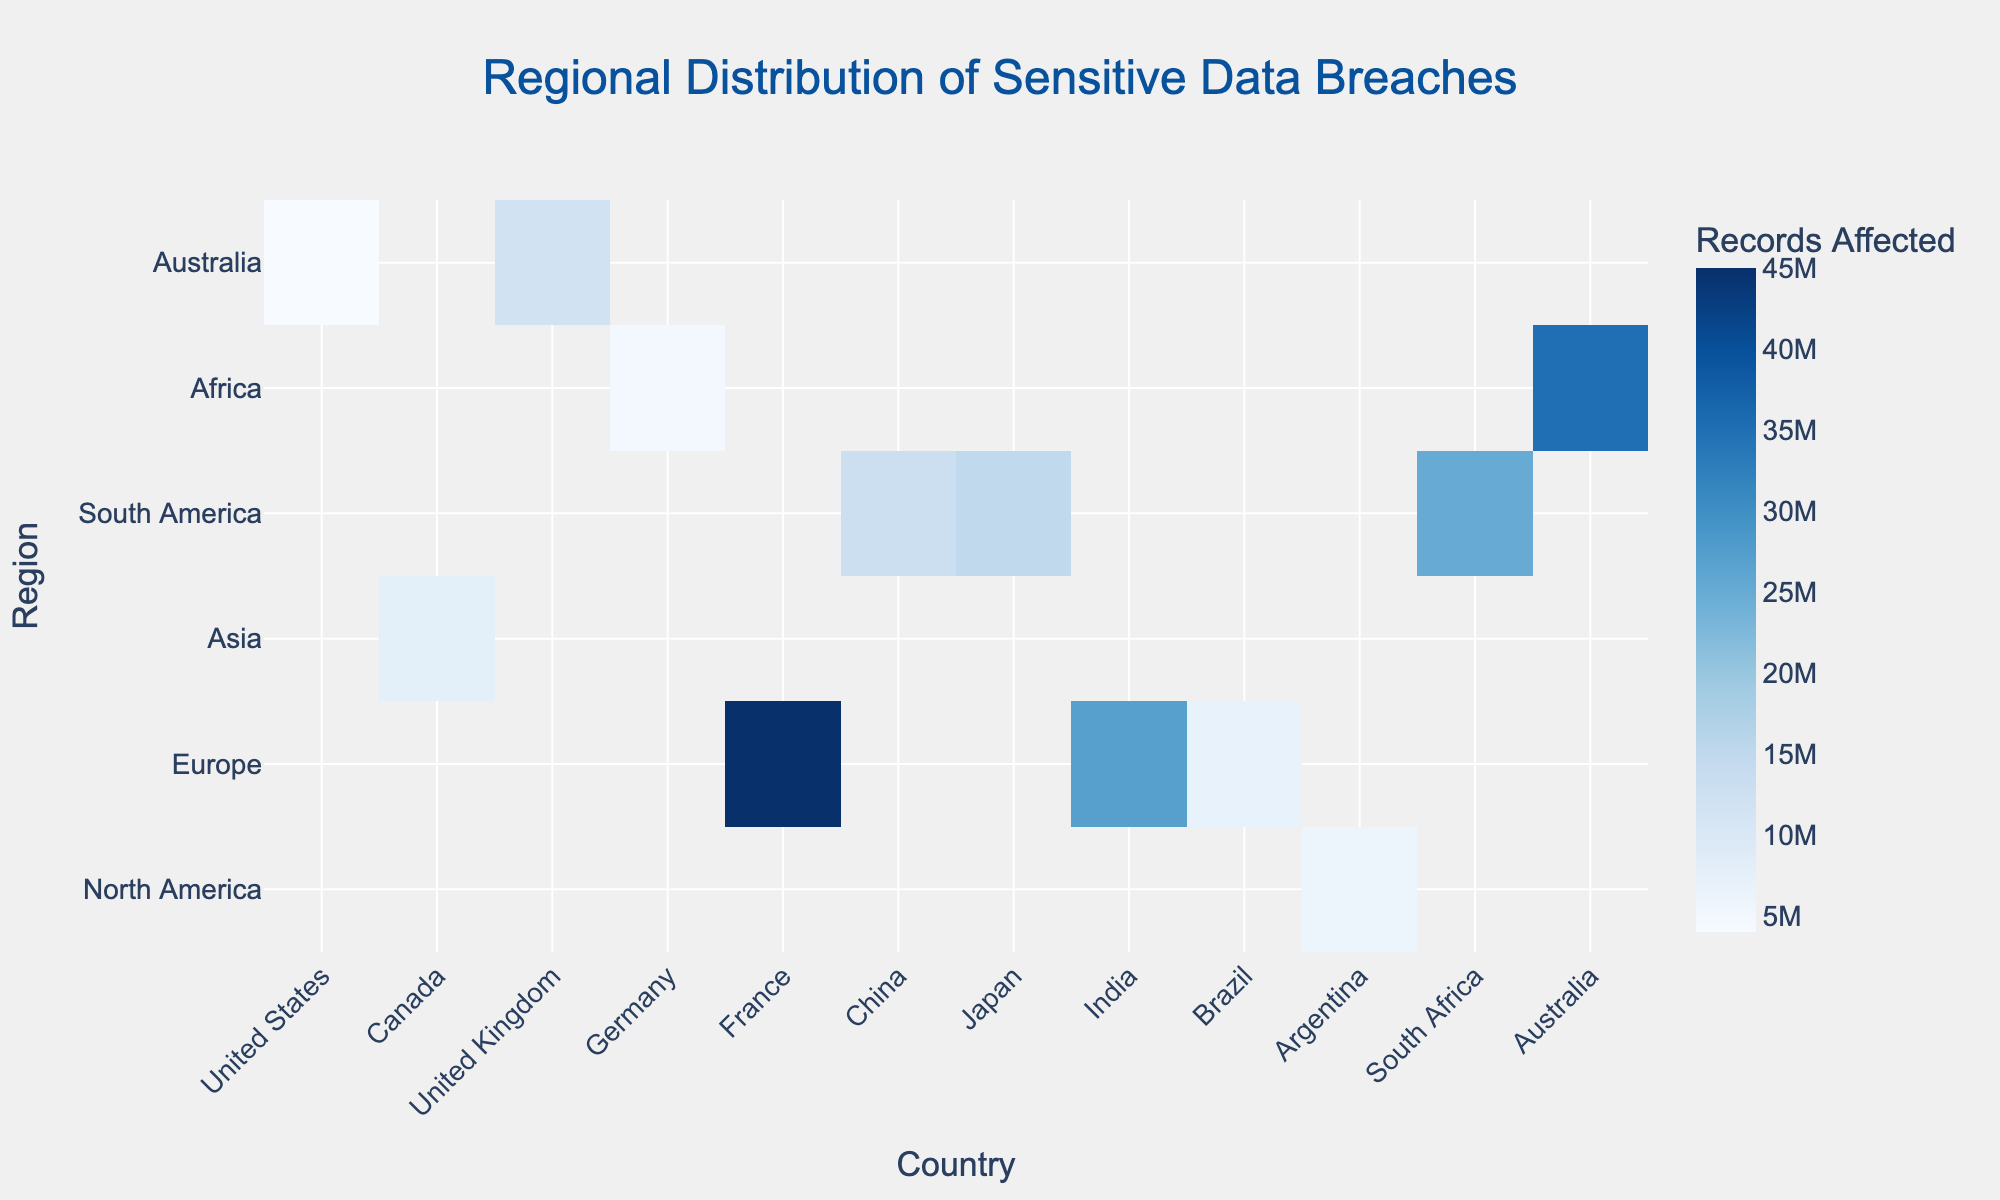what is the title of the figure? The title is usually placed at the top of the figure. In this case, it is centered and at the top.
Answer: Regional Distribution of Sensitive Data Breaches Which country in North America has the highest records affected? Look at the color intensity in the North America region, which includes countries like the United States and Canada. The United States has the highest color intensity.
Answer: United States Which region has the highest total number of breaches? Look at the custom data values for each region and sum them. North America: 50+10, Europe: 30+25+20, Asia: 40+15+35, South America: 20+10, Africa: 15, Australia:10. Asia has the highest total: 40+15+35=90.
Answer: Asia Which country has the least number of breaches in Europe? Look at the custom data for each country in Europe and find the lowest value. United Kingdom: 30, Germany: 25, France: 20. France has the least number.
Answer: France What is the combined records affected for China and India? Sum the records affected in China and India. China: 45,000,000 and India: 27,000,000. So, 45,000,000 + 27,000,000 = 72,000,000.
Answer: 72,000,000 Compare the number of breaches in Japan and South Africa. Which country has more breaches? Compare the custom data values for Japan and South Africa. Japan: 15, South Africa: 15. They are equal.
Answer: Equal Which country has more breaches: Brazil or Australia? Look at the custom data for both countries. Brazil has 20 breaches, and Australia has 10.
Answer: Brazil Which region has more affected records: North America or Europe? Sum the records in North America and Europe. North America: 35,000,000 + 5,000,000 = 40,000,000. Europe: 25,000,000 + 15,000,000 + 13,000,000 = 53,000,000. Europe has more.
Answer: Europe What is the average number of records affected in South America? South America consists of Brazil and Argentina. Sum the records and divide by 2. (12,000,000 + 4,000,000) / 2 = 8,000,000.
Answer: 8,000,000 